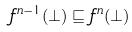<formula> <loc_0><loc_0><loc_500><loc_500>f ^ { n - 1 } ( \perp ) \sqsubseteq f ^ { n } ( \perp )</formula> 